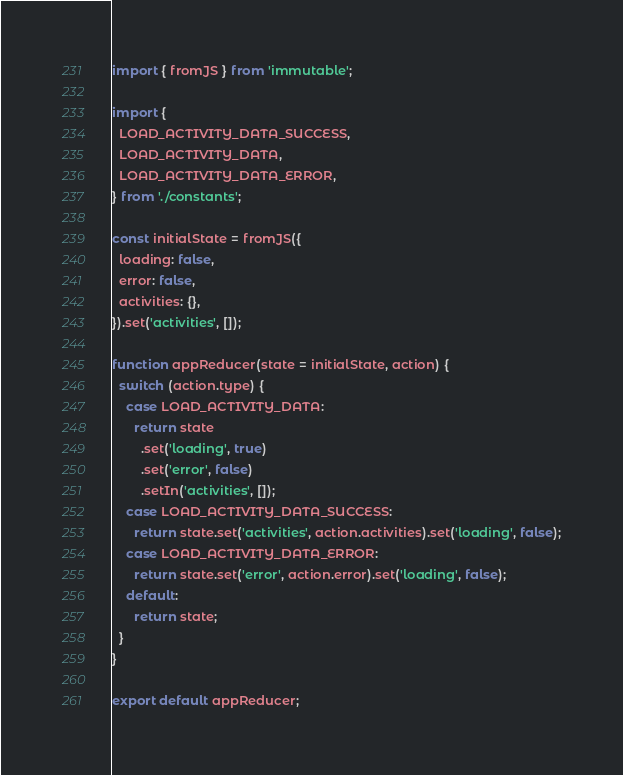Convert code to text. <code><loc_0><loc_0><loc_500><loc_500><_JavaScript_>import { fromJS } from 'immutable';

import {
  LOAD_ACTIVITY_DATA_SUCCESS,
  LOAD_ACTIVITY_DATA,
  LOAD_ACTIVITY_DATA_ERROR,
} from './constants';

const initialState = fromJS({
  loading: false,
  error: false,
  activities: {},
}).set('activities', []);

function appReducer(state = initialState, action) {
  switch (action.type) {
    case LOAD_ACTIVITY_DATA:
      return state
        .set('loading', true)
        .set('error', false)
        .setIn('activities', []);
    case LOAD_ACTIVITY_DATA_SUCCESS:
      return state.set('activities', action.activities).set('loading', false);
    case LOAD_ACTIVITY_DATA_ERROR:
      return state.set('error', action.error).set('loading', false);
    default:
      return state;
  }
}

export default appReducer;
</code> 